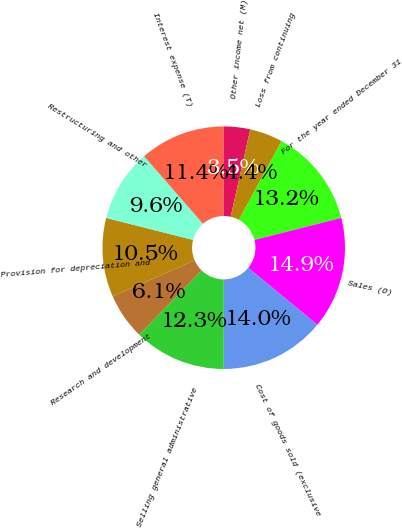Convert chart to OTSL. <chart><loc_0><loc_0><loc_500><loc_500><pie_chart><fcel>For the year ended December 31<fcel>Sales (O)<fcel>Cost of goods sold (exclusive<fcel>Selling general administrative<fcel>Research and development<fcel>Provision for depreciation and<fcel>Restructuring and other<fcel>Interest expense (T)<fcel>Other income net (M)<fcel>Loss from continuing<nl><fcel>13.16%<fcel>14.91%<fcel>14.04%<fcel>12.28%<fcel>6.14%<fcel>10.53%<fcel>9.65%<fcel>11.4%<fcel>3.51%<fcel>4.39%<nl></chart> 